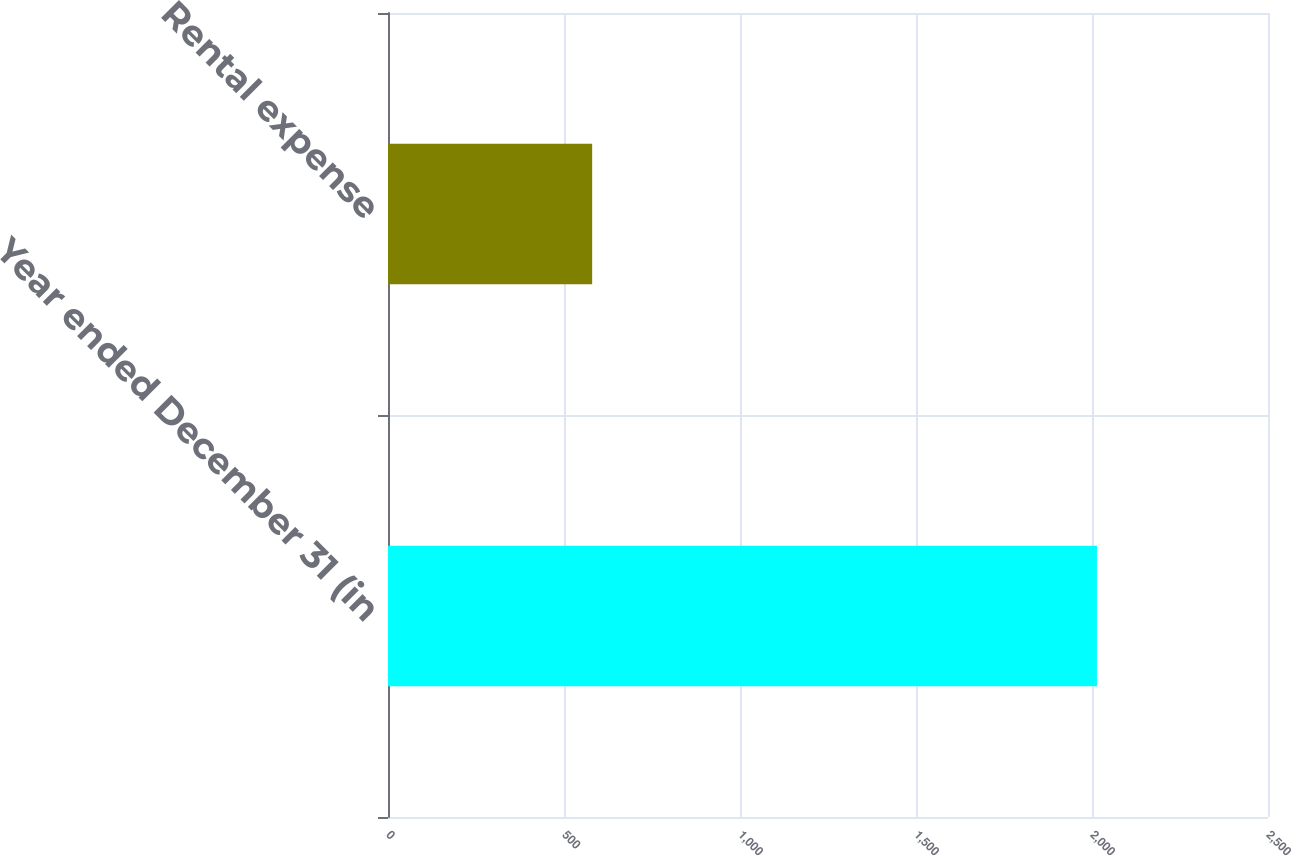<chart> <loc_0><loc_0><loc_500><loc_500><bar_chart><fcel>Year ended December 31 (in<fcel>Rental expense<nl><fcel>2014<fcel>580<nl></chart> 